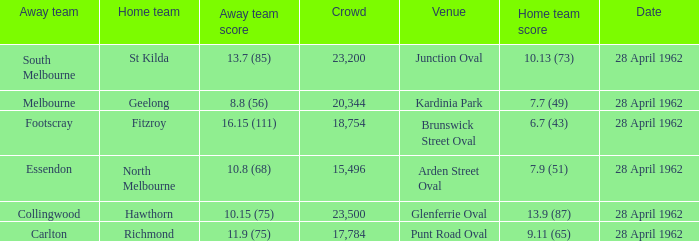What was the crowd size when there was a home team score of 10.13 (73)? 23200.0. 